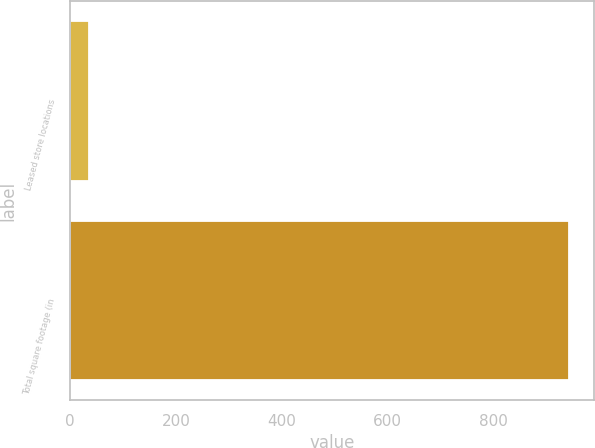<chart> <loc_0><loc_0><loc_500><loc_500><bar_chart><fcel>Leased store locations<fcel>Total square footage (in<nl><fcel>35<fcel>944<nl></chart> 